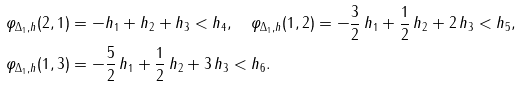Convert formula to latex. <formula><loc_0><loc_0><loc_500><loc_500>\varphi _ { \Delta _ { 1 } , h } ( 2 , 1 ) & = - h _ { 1 } + h _ { 2 } + h _ { 3 } < h _ { 4 } , \quad \varphi _ { \Delta _ { 1 } , h } ( 1 , 2 ) = - \frac { 3 } { 2 } \, h _ { 1 } + \frac { 1 } { 2 } \, h _ { 2 } + 2 \, h _ { 3 } < h _ { 5 } , \\ \varphi _ { \Delta _ { 1 } , h } ( 1 , 3 ) & = - \frac { 5 } { 2 } \, h _ { 1 } + \frac { 1 } { 2 } \, h _ { 2 } + 3 \, h _ { 3 } < h _ { 6 } .</formula> 